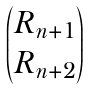Convert formula to latex. <formula><loc_0><loc_0><loc_500><loc_500>\begin{pmatrix} R _ { n + 1 } \\ R _ { n + 2 } \end{pmatrix}</formula> 